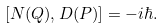<formula> <loc_0><loc_0><loc_500><loc_500>[ N ( Q ) , D ( P ) ] = - i \hbar { . }</formula> 